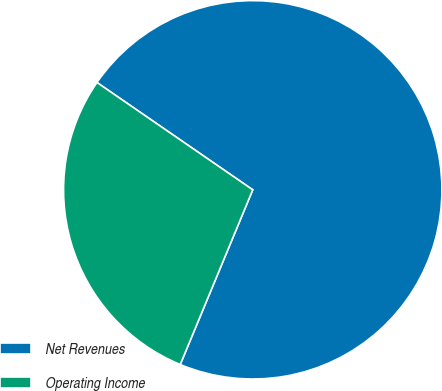<chart> <loc_0><loc_0><loc_500><loc_500><pie_chart><fcel>Net Revenues<fcel>Operating Income<nl><fcel>71.66%<fcel>28.34%<nl></chart> 